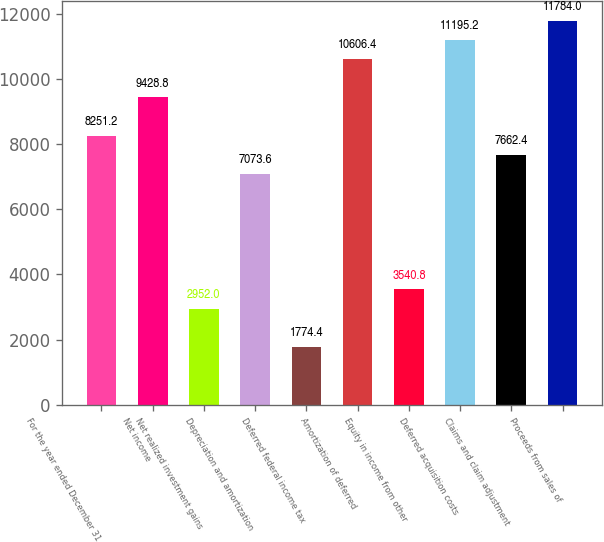Convert chart. <chart><loc_0><loc_0><loc_500><loc_500><bar_chart><fcel>For the year ended December 31<fcel>Net income<fcel>Net realized investment gains<fcel>Depreciation and amortization<fcel>Deferred federal income tax<fcel>Amortization of deferred<fcel>Equity in income from other<fcel>Deferred acquisition costs<fcel>Claims and claim adjustment<fcel>Proceeds from sales of<nl><fcel>8251.2<fcel>9428.8<fcel>2952<fcel>7073.6<fcel>1774.4<fcel>10606.4<fcel>3540.8<fcel>11195.2<fcel>7662.4<fcel>11784<nl></chart> 